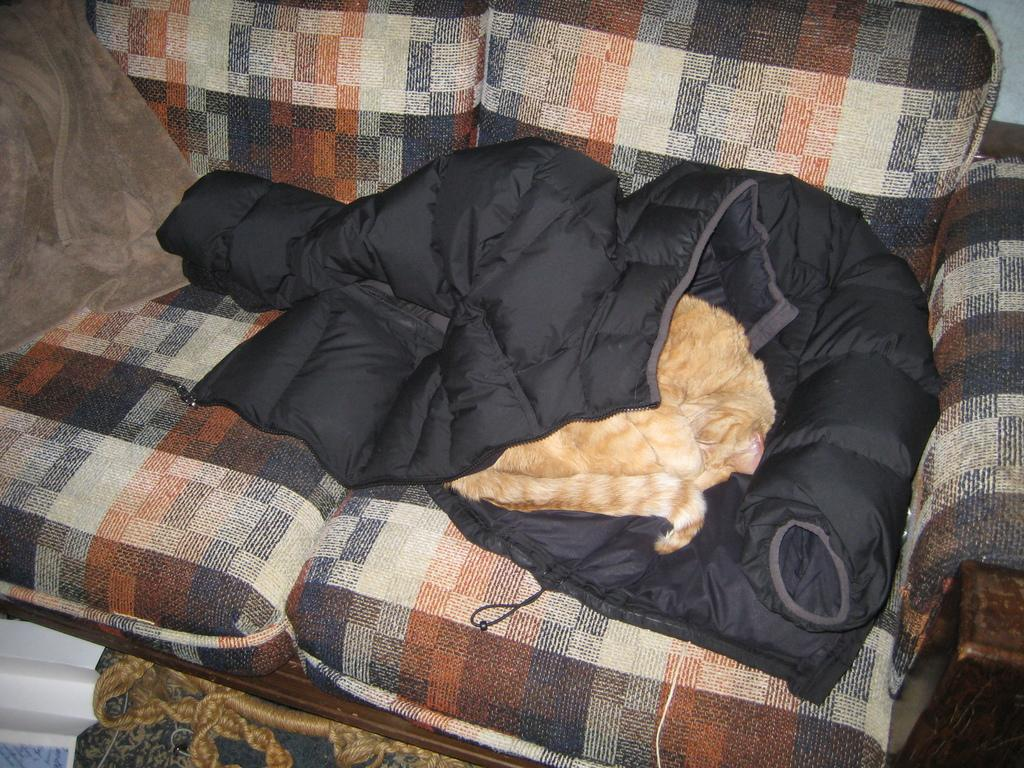What type of animal is in the image? The type of animal cannot be determined from the provided facts. Where is the animal located in the image? The animal is on a sofa. What else is on the sofa in the image? There are clothes on the sofa. What brand of toothpaste is the animal using in the image? There is no toothpaste or indication of toothpaste use in the image. 